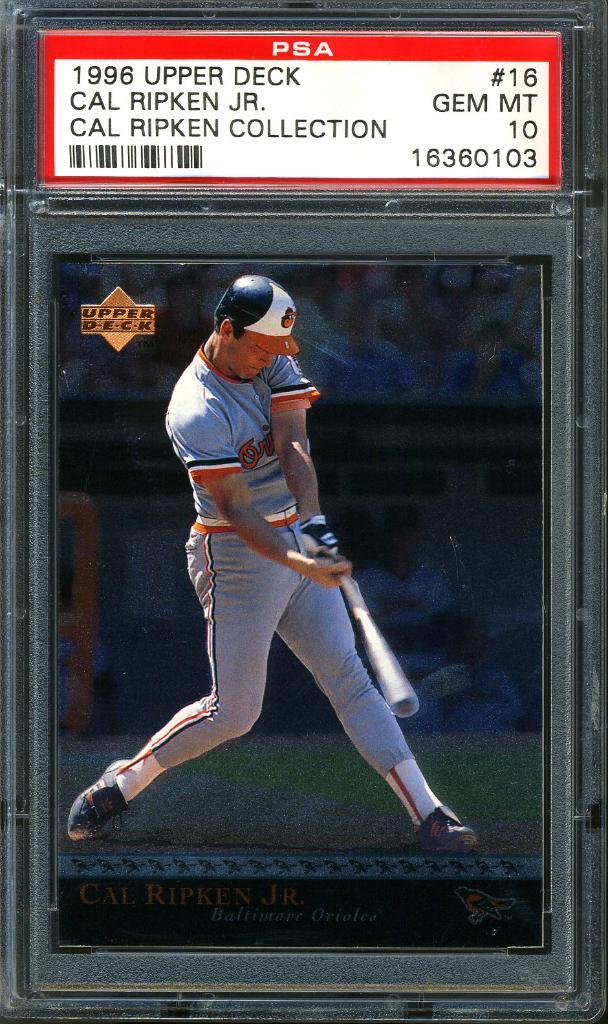<image>
Give a short and clear explanation of the subsequent image. A 1996 Cal Ripken Jr. collectible baseball card 